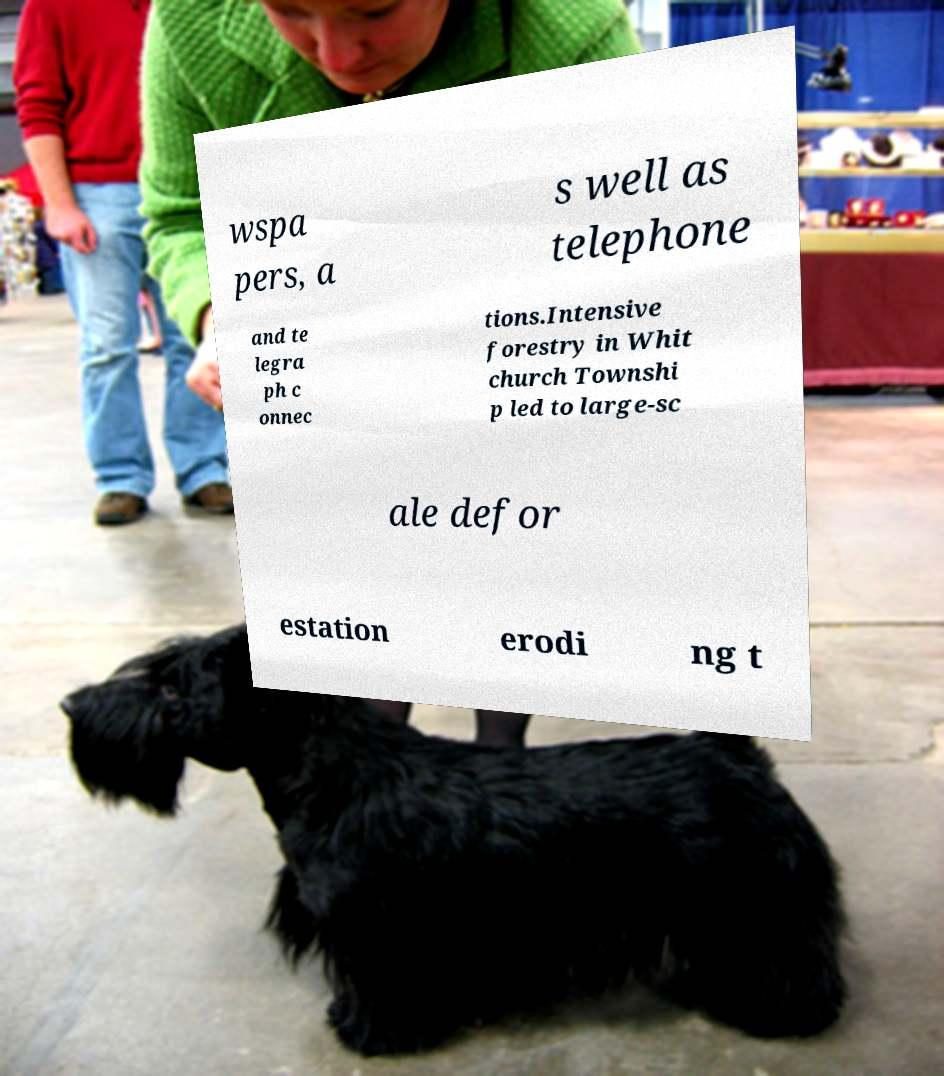Please identify and transcribe the text found in this image. wspa pers, a s well as telephone and te legra ph c onnec tions.Intensive forestry in Whit church Townshi p led to large-sc ale defor estation erodi ng t 